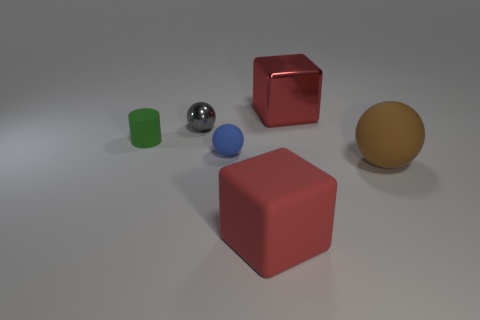Subtract all small spheres. How many spheres are left? 1 Add 1 rubber balls. How many objects exist? 7 Subtract all blue balls. How many balls are left? 2 Subtract all cubes. How many objects are left? 4 Subtract all green blocks. Subtract all red spheres. How many blocks are left? 2 Subtract all gray cylinders. How many brown blocks are left? 0 Subtract all big red metallic spheres. Subtract all rubber things. How many objects are left? 2 Add 3 brown matte things. How many brown matte things are left? 4 Add 3 gray cylinders. How many gray cylinders exist? 3 Subtract 0 blue cylinders. How many objects are left? 6 